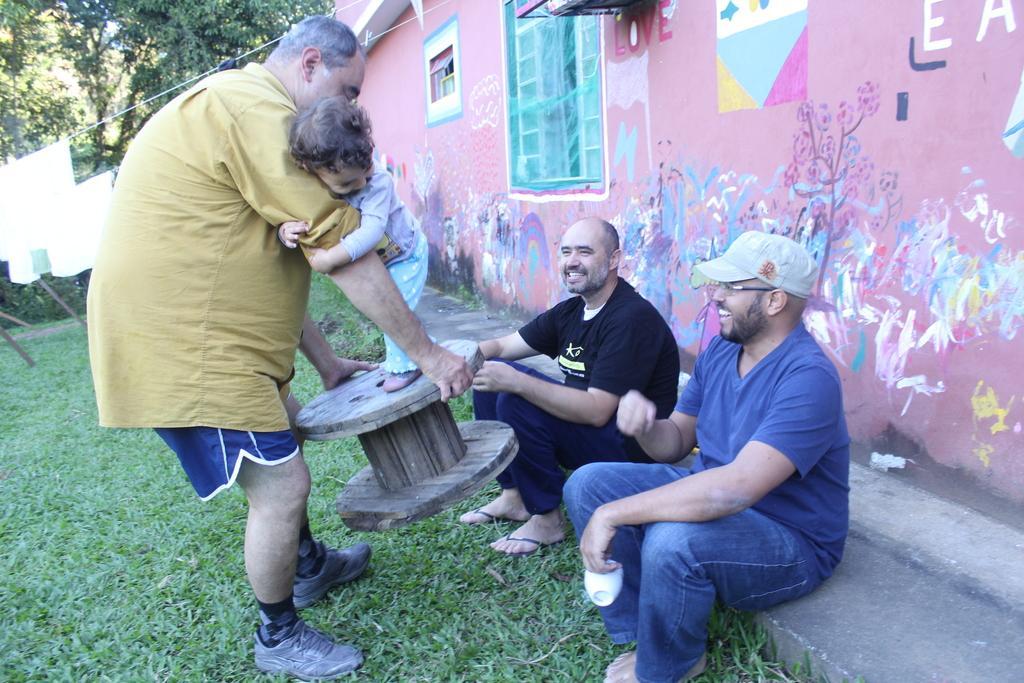Please provide a concise description of this image. Here we can see three men and a kid. They are smiling. This is grass. In the background we can see a wall, window, painting, and trees. 